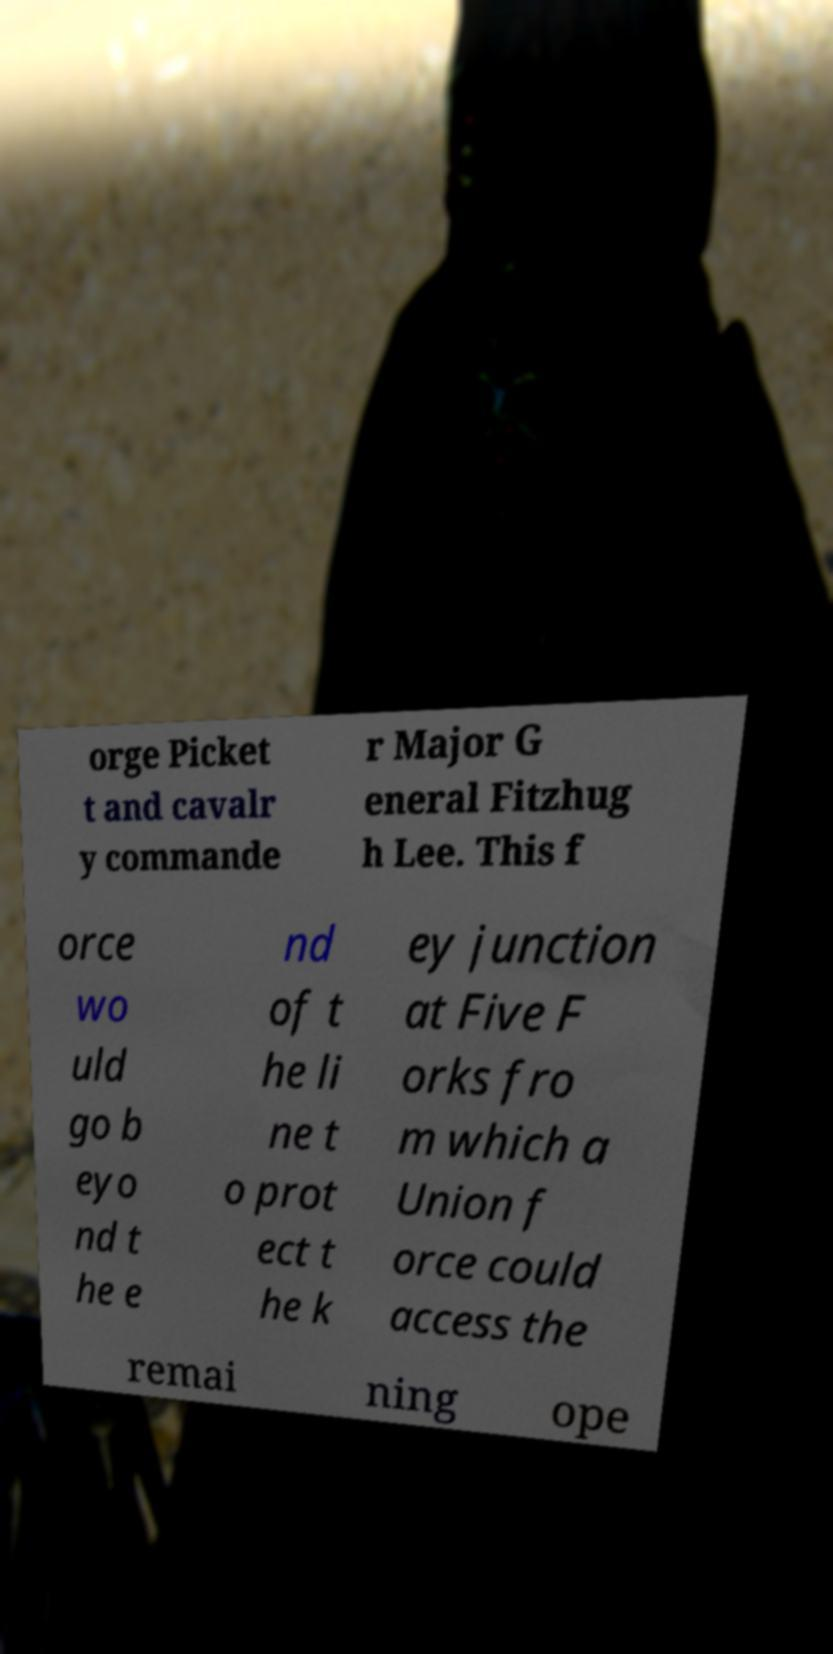I need the written content from this picture converted into text. Can you do that? orge Picket t and cavalr y commande r Major G eneral Fitzhug h Lee. This f orce wo uld go b eyo nd t he e nd of t he li ne t o prot ect t he k ey junction at Five F orks fro m which a Union f orce could access the remai ning ope 